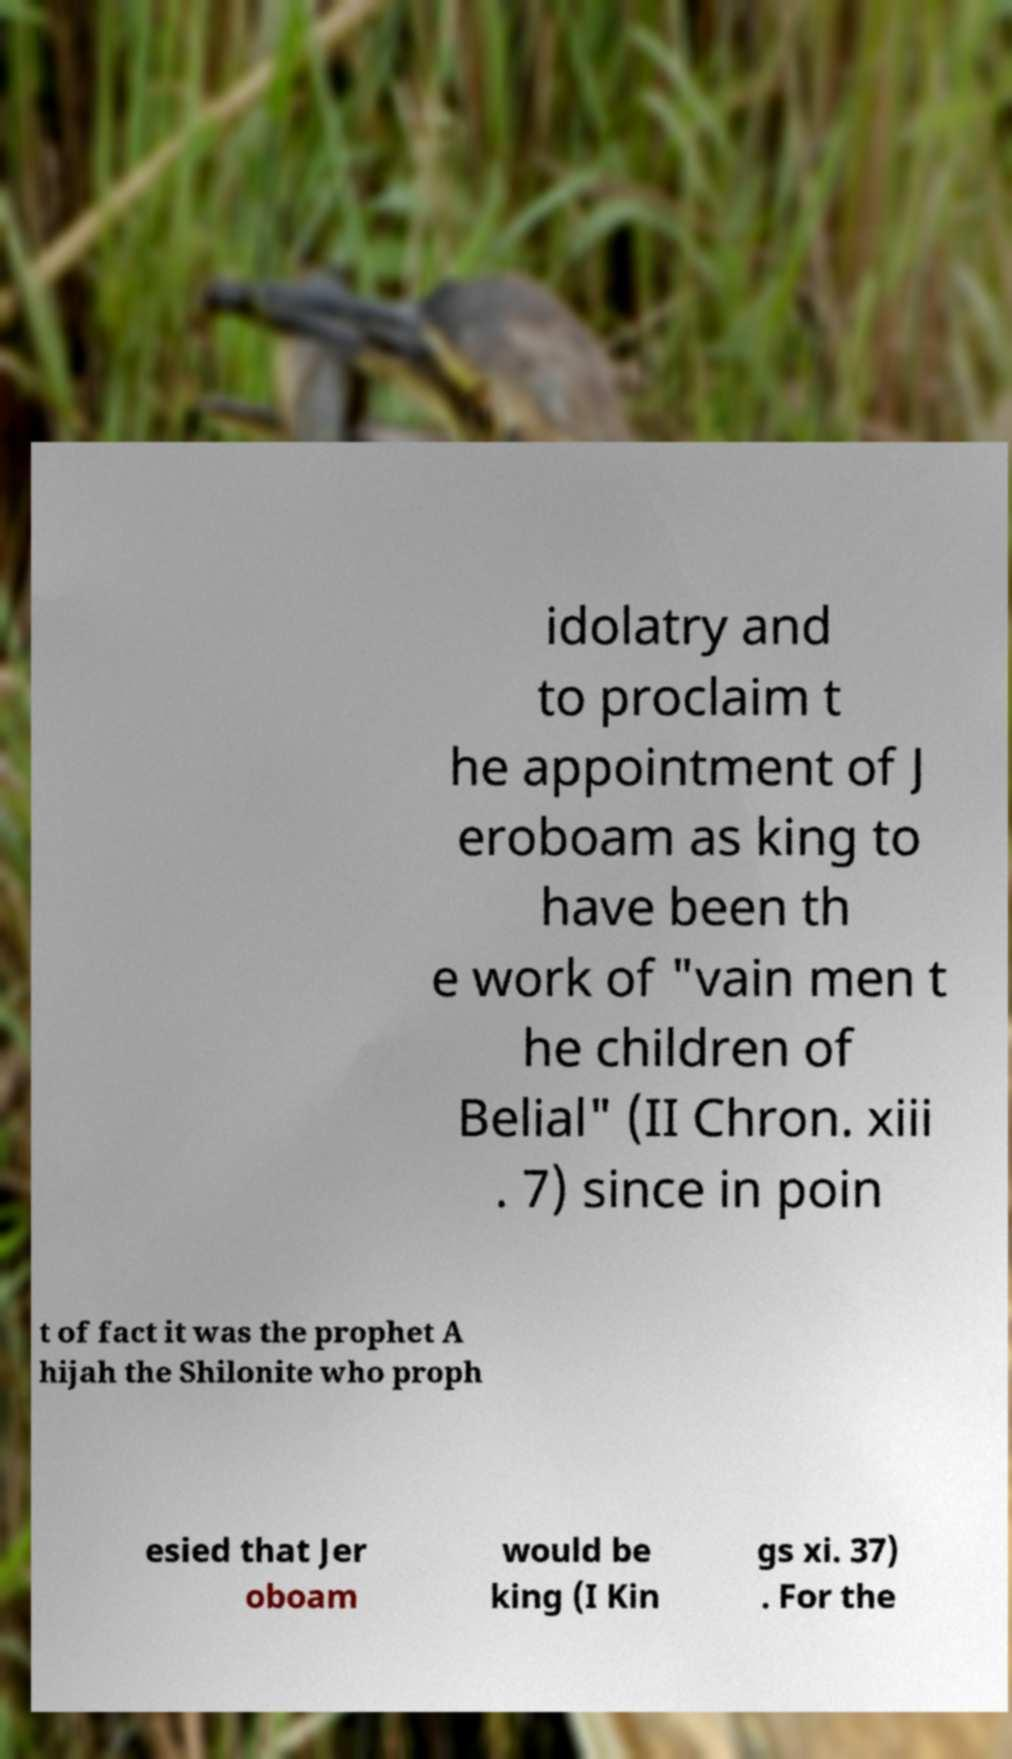Please identify and transcribe the text found in this image. idolatry and to proclaim t he appointment of J eroboam as king to have been th e work of "vain men t he children of Belial" (II Chron. xiii . 7) since in poin t of fact it was the prophet A hijah the Shilonite who proph esied that Jer oboam would be king (I Kin gs xi. 37) . For the 